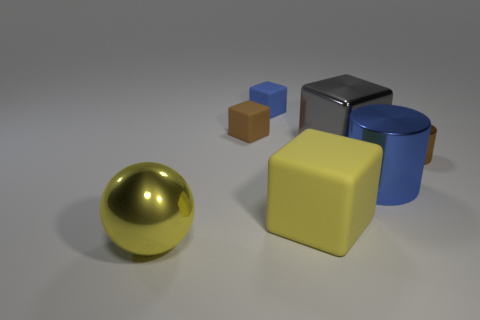What is the color of the large cube that is behind the yellow thing that is on the right side of the large yellow shiny thing?
Ensure brevity in your answer.  Gray. How many cubes are blue rubber things or large gray things?
Provide a short and direct response. 2. What number of things are both in front of the brown cube and on the right side of the large yellow sphere?
Your answer should be compact. 4. There is a shiny block that is in front of the brown block; what is its color?
Your answer should be compact. Gray. There is a cube that is the same material as the blue cylinder; what size is it?
Your answer should be very brief. Large. What number of large blue objects are behind the thing that is behind the small brown rubber thing?
Offer a very short reply. 0. There is a yellow rubber block; what number of cylinders are on the left side of it?
Offer a very short reply. 0. What color is the large thing that is in front of the large yellow thing right of the yellow thing that is in front of the large yellow matte cube?
Offer a terse response. Yellow. There is a matte block to the right of the blue block; is it the same color as the metallic object that is left of the blue rubber cube?
Your response must be concise. Yes. There is a yellow object to the right of the shiny object in front of the large blue metallic object; what shape is it?
Your response must be concise. Cube. 